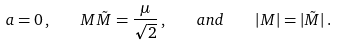Convert formula to latex. <formula><loc_0><loc_0><loc_500><loc_500>a = 0 \, , \quad M \tilde { M } = \frac { \mu } { \sqrt { 2 } } \, , \quad a n d \quad \left | M \right | = | \tilde { M } | \, .</formula> 